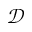<formula> <loc_0><loc_0><loc_500><loc_500>\mathcal { D }</formula> 